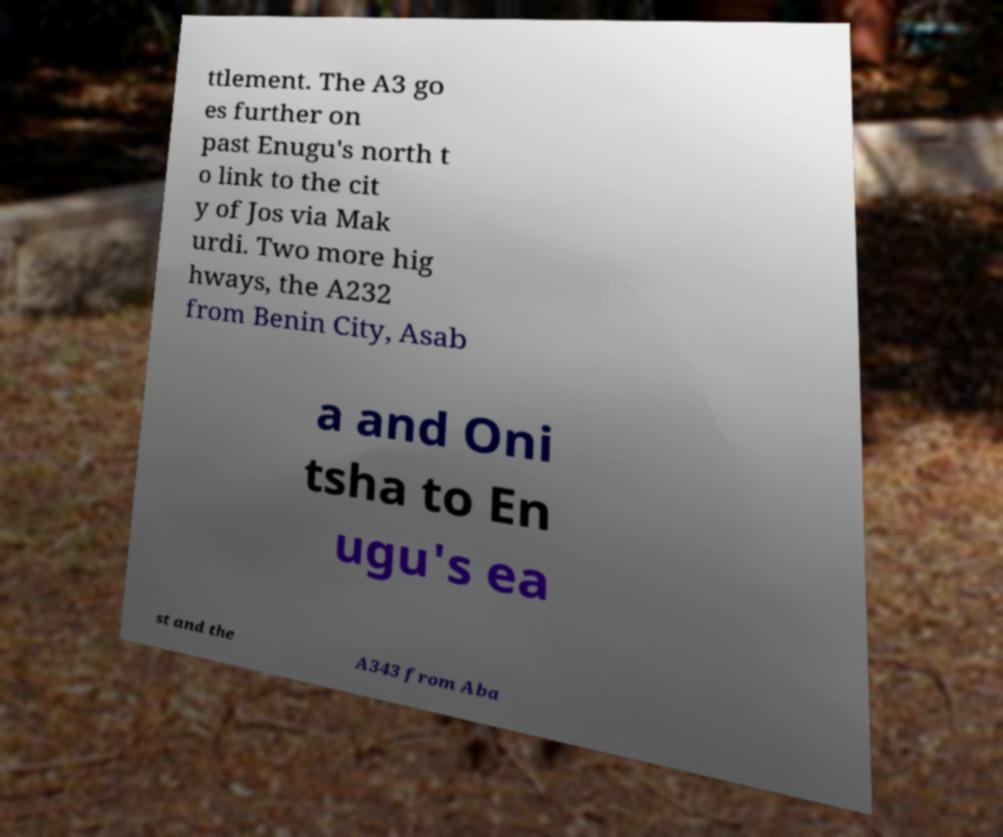Can you accurately transcribe the text from the provided image for me? ttlement. The A3 go es further on past Enugu's north t o link to the cit y of Jos via Mak urdi. Two more hig hways, the A232 from Benin City, Asab a and Oni tsha to En ugu's ea st and the A343 from Aba 